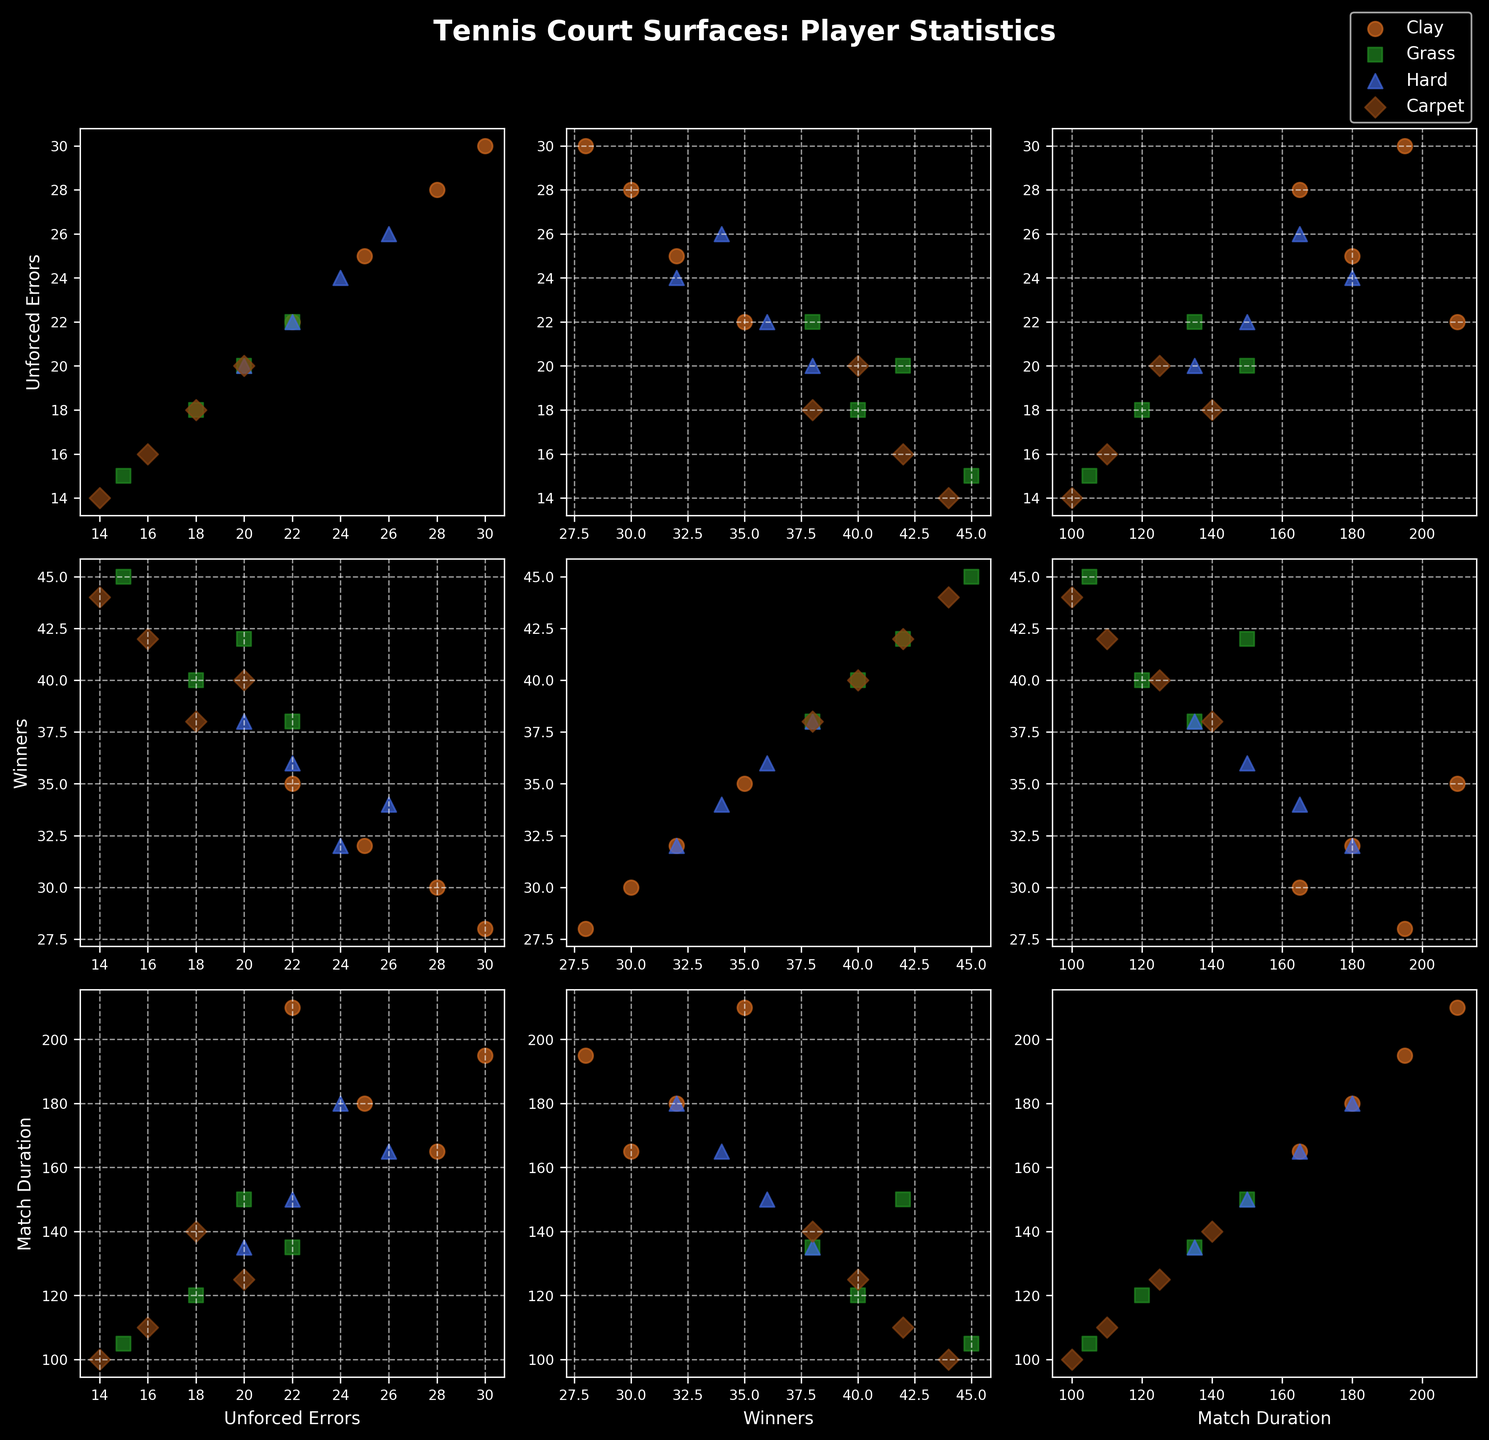Which surface is represented by the green squares? The legend in the scatterplot matrix indicates the color and marker style for each surface. Green squares represent "Grass" as per the specified mapping in the legend.
Answer: Grass How many data points are plotted for the "Clay" surface? Each data point corresponds to a row in the dataset for a specific surface. By counting the rows labeled "Clay" in the dataset, we see there are four data points.
Answer: Four Which statistic pair shows the largest spread in values for the "Grass" surface? By observing the scatterplots for the "Grass" surface, we look for the pair with the widest dispersion. Here, the pair "Winners" vs. "Unforced Errors" has the largest spread seen from the scatterplot.
Answer: Winners vs. Unforced Errors What is the average match duration for the "Hard" surface? The match durations for "Hard" are 150, 165, 135, and 180 minutes. Summing these values: 150 + 165 + 135 + 180 = 630. Dividing by 4, the average is 630/4 = 157.5 minutes.
Answer: 157.5 minutes Which surface has the highest peak of "Winners" recorded and what is that value? By looking at the scatterplots for "Winners", we note that the "Grass" surface has the highest point, which corresponds to 45.
Answer: Grass, 45 Compare "Clay" and "Carpet" in terms of average "Unforced Errors". Which one is higher? For "Clay", Unforced Errors are 25, 30, 22, and 28. Their average is (25 + 30 + 22 + 28)/4 = 26.25. For "Carpet", they are 16, 20, 14, and 18, averaging (16 + 20 + 14 + 18)/4 = 17. Rounding, "Clay" has a higher average.
Answer: Clay Is there a positive or negative correlation between "Match Duration" and "Unforced Errors" on "Clay"? By looking at the scatterplot for "Match Duration" vs. "Unforced Errors" specific to "Clay", we observe it. The trendline from the scattered data points indicates a slight positive correlation.
Answer: Positive correlation Which surface typically has the shortest match durations? Checking "Match Duration" scatterplots, "Carpet" surface shows the shortest durations, with values around 100 to 140 minutes.
Answer: Carpet What is the trend between "Winners" and "Unforced Errors" for the "Carpet" surface? Observing the scatterplot for "Winners" versus "Unforced Errors" on "Carpet", it shows a slight positive trend, indicating that higher "Unforced Errors" correspond with more "Winners."
Answer: Slight positive trend 